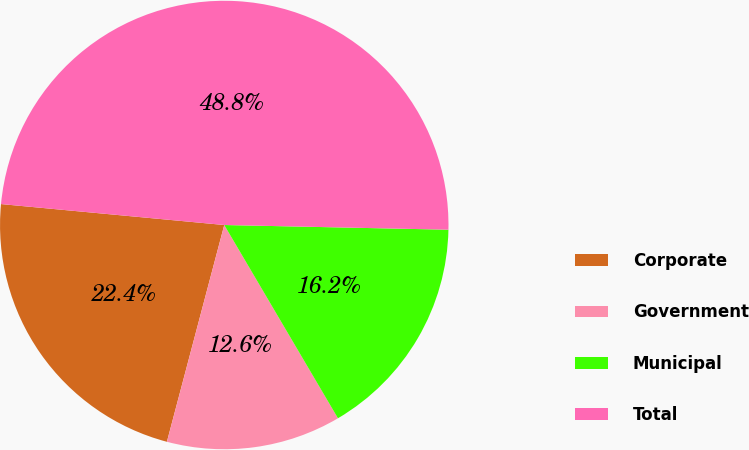Convert chart. <chart><loc_0><loc_0><loc_500><loc_500><pie_chart><fcel>Corporate<fcel>Government<fcel>Municipal<fcel>Total<nl><fcel>22.37%<fcel>12.58%<fcel>16.2%<fcel>48.84%<nl></chart> 